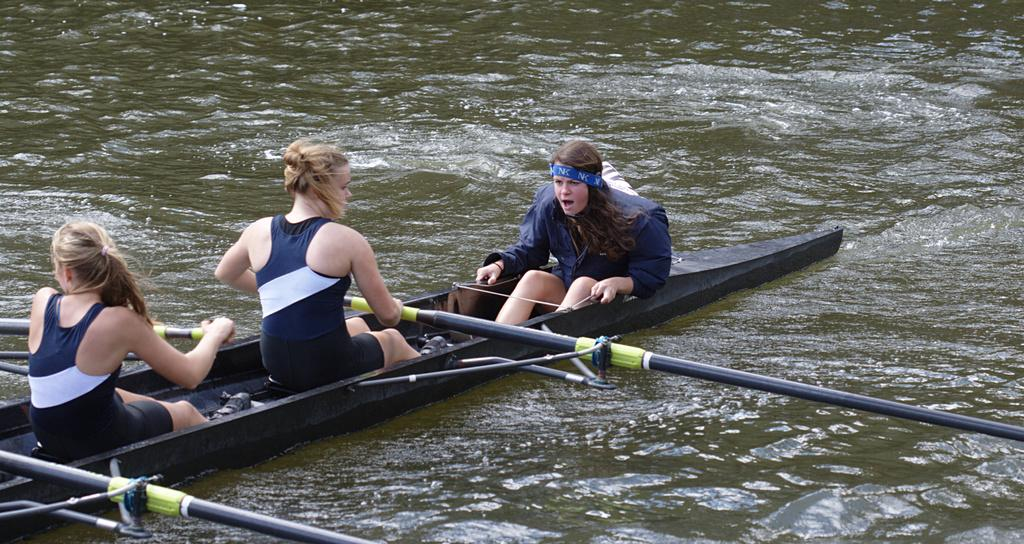How many people are in the image? There are three women in the image. What are the women doing in the image? The women are rowing a boat. What colors are present on the women's tops? The women are wearing tops with colors blue and white. What type of environment is visible in the image? There is water visible in the image. What type of frame is holding the yarn in the image? There is no frame or yarn present in the image. How hot is the water in the image? The temperature of the water is not mentioned in the image, so we cannot determine how hot it is. 